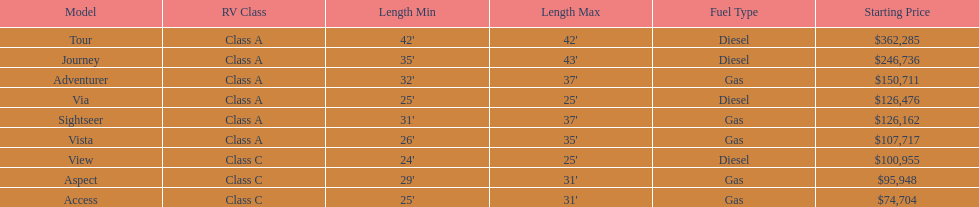Which model had the highest starting price Tour. 